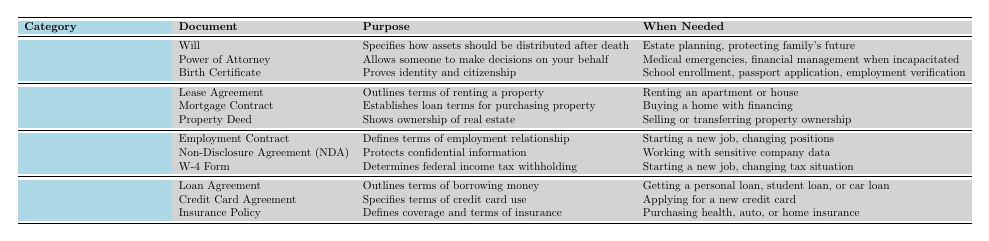What document specifies how a person's assets should be distributed after death? The table indicates that the document named "Will" specifies how a person's assets should be distributed after death.
Answer: Will In which category would you find the Birth Certificate? The Birth Certificate is listed under the "Personal Documents" category in the table.
Answer: Personal Documents How many types of Housing Documents are listed? The table shows three types of Housing Documents: Lease Agreement, Mortgage Contract, and Property Deed, which totals to three.
Answer: 3 What is the purpose of a Non-Disclosure Agreement (NDA)? According to the table, a Non-Disclosure Agreement (NDA) protects confidential information.
Answer: Protects confidential information When is a Property Deed needed? The table indicates that a Property Deed is needed when selling or transferring property ownership.
Answer: Selling or transferring property ownership Is an Insurance Policy part of Employment Documents? The table shows that an Insurance Policy is categorized under Financial Documents, not Employment Documents, so the answer is no.
Answer: No Which document is required for school enrollment? The Birth Certificate is stated in the table as the document needed for school enrollment.
Answer: Birth Certificate If someone is starting a new job, which form would they need related to tax? The W-4 Form is mentioned in the table as the document needed for determining federal income tax withholding when starting a new job.
Answer: W-4 Form How many documents are listed under Financial Documents? There are three documents listed under Financial Documents in the table: Loan Agreement, Credit Card Agreement, and Insurance Policy. Therefore, the total is three.
Answer: 3 If a person needed to apply for a new credit card, what document would they refer to? The table indicates that the Credit Card Agreement is the document to refer to when applying for a new credit card.
Answer: Credit Card Agreement What is the main purpose of a Lease Agreement? The Lease Agreement is stated in the table to outline the terms of renting a property, which highlights its main purpose.
Answer: Outlines terms of renting a property 